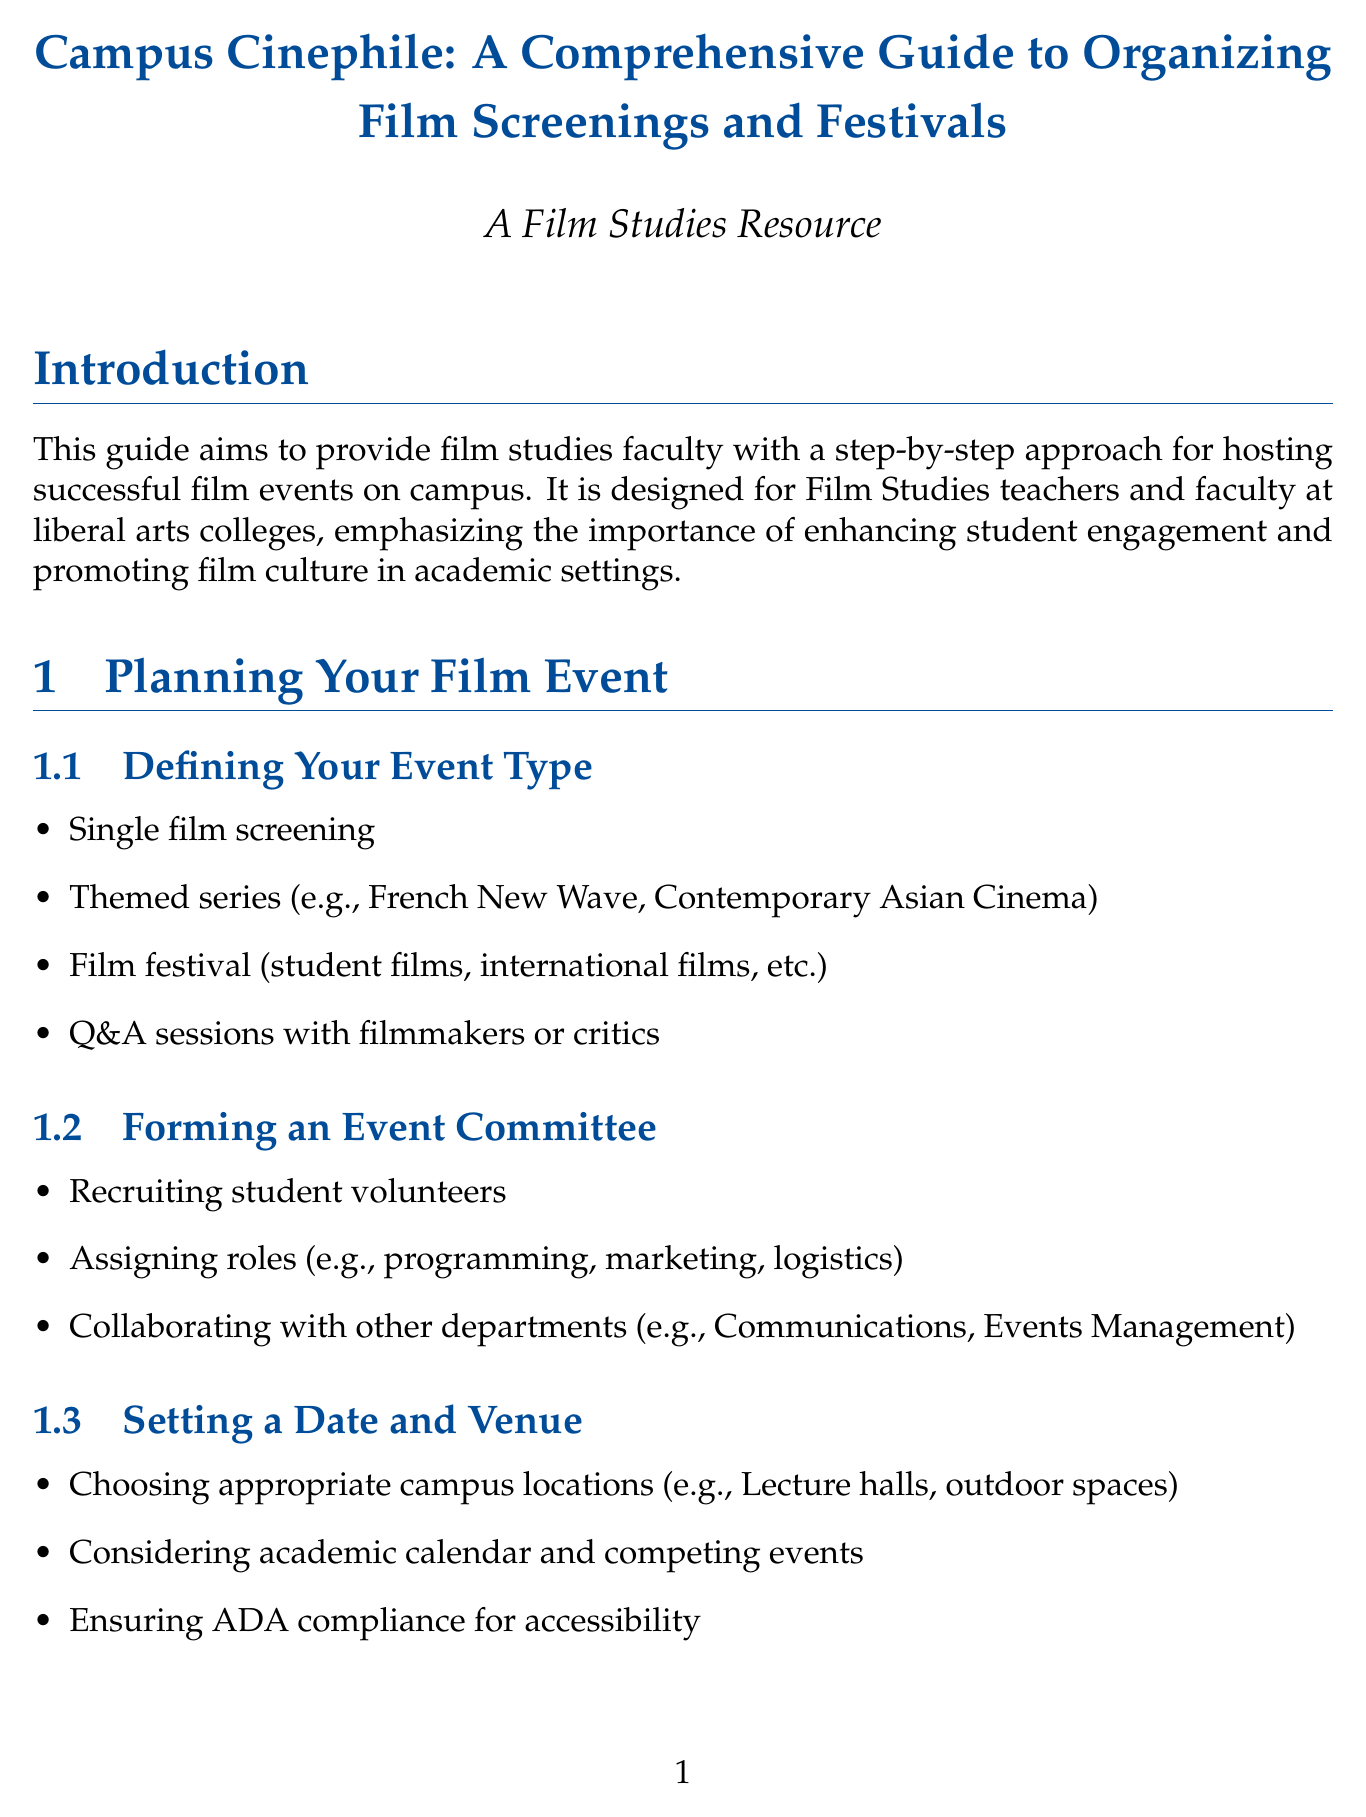What is the title of the handbook? The title is provided at the beginning of the document, which indicates the focus and purpose of the contents.
Answer: Campus Cinephile: A Comprehensive Guide to Organizing Film Screenings and Festivals Who is the target audience for this handbook? The document specifies that the handbook is designed for a specific group within academic institutions, which is stated clearly in the introduction section.
Answer: Film Studies teachers and faculty at liberal arts colleges What should be included in the event committee formation? This detail is outlined under a specific section that discusses the roles and responsibilities involved in organizing an event.
Answer: Recruiting student volunteers What type of licensing rights are discussed? The handbook mentions various specific rights that need to be understood when organizing film screenings, as highlighted in the licensing and copyright considerations chapter.
Answer: Public performance rights What is one of the marketing strategies suggested? The document lists various strategies for promoting film events, specifying ways to engage with the campus community.
Answer: Utilizing campus media Which section covers post-event evaluation? The handbook is structured into chapters and sections that systematically address the entire process of organizing film events, including reviewing their success.
Answer: Post-Event Evaluation and Follow-up What equipment is suggested for technical needs? This information is found in a dedicated section that emphasizes the essential technological requirements for successful screenings.
Answer: Projectors and screens How can funding be secured according to the handbook? This detail encompasses various methods presented in the budgeting and funding section, clarifying financial strategies available to faculty.
Answer: Applying for departmental or college grants What kind of resources are included in the appendices? The appendices provide additional materials that are useful for faculty, enhancing the practical application of the handbook.
Answer: List of film distributors and their contact information 